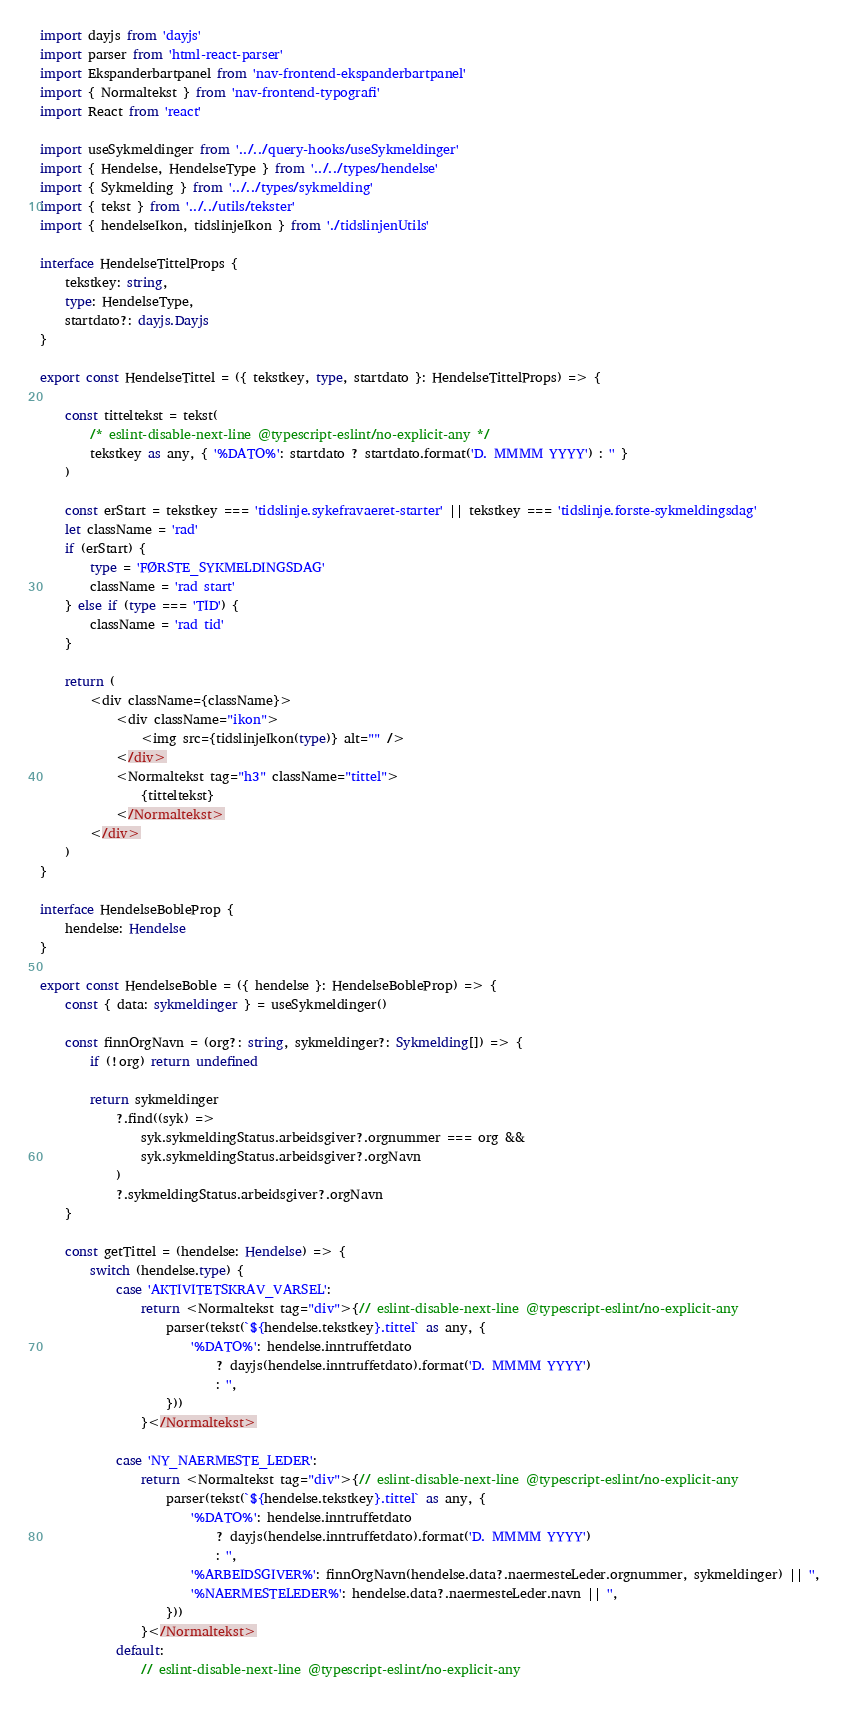<code> <loc_0><loc_0><loc_500><loc_500><_TypeScript_>import dayjs from 'dayjs'
import parser from 'html-react-parser'
import Ekspanderbartpanel from 'nav-frontend-ekspanderbartpanel'
import { Normaltekst } from 'nav-frontend-typografi'
import React from 'react'

import useSykmeldinger from '../../query-hooks/useSykmeldinger'
import { Hendelse, HendelseType } from '../../types/hendelse'
import { Sykmelding } from '../../types/sykmelding'
import { tekst } from '../../utils/tekster'
import { hendelseIkon, tidslinjeIkon } from './tidslinjenUtils'

interface HendelseTittelProps {
    tekstkey: string,
    type: HendelseType,
    startdato?: dayjs.Dayjs
}

export const HendelseTittel = ({ tekstkey, type, startdato }: HendelseTittelProps) => {

    const titteltekst = tekst(
        /* eslint-disable-next-line @typescript-eslint/no-explicit-any */
        tekstkey as any, { '%DATO%': startdato ? startdato.format('D. MMMM YYYY') : '' }
    )

    const erStart = tekstkey === 'tidslinje.sykefravaeret-starter' || tekstkey === 'tidslinje.forste-sykmeldingsdag'
    let className = 'rad'
    if (erStart) {
        type = 'FØRSTE_SYKMELDINGSDAG'
        className = 'rad start'
    } else if (type === 'TID') {
        className = 'rad tid'
    }

    return (
        <div className={className}>
            <div className="ikon">
                <img src={tidslinjeIkon(type)} alt="" />
            </div>
            <Normaltekst tag="h3" className="tittel">
                {titteltekst}
            </Normaltekst>
        </div>
    )
}

interface HendelseBobleProp {
    hendelse: Hendelse
}

export const HendelseBoble = ({ hendelse }: HendelseBobleProp) => {
    const { data: sykmeldinger } = useSykmeldinger()

    const finnOrgNavn = (org?: string, sykmeldinger?: Sykmelding[]) => {
        if (!org) return undefined

        return sykmeldinger
            ?.find((syk) =>
                syk.sykmeldingStatus.arbeidsgiver?.orgnummer === org &&
                syk.sykmeldingStatus.arbeidsgiver?.orgNavn
            )
            ?.sykmeldingStatus.arbeidsgiver?.orgNavn
    }

    const getTittel = (hendelse: Hendelse) => {
        switch (hendelse.type) {
            case 'AKTIVITETSKRAV_VARSEL':
                return <Normaltekst tag="div">{// eslint-disable-next-line @typescript-eslint/no-explicit-any
                    parser(tekst(`${hendelse.tekstkey}.tittel` as any, {
                        '%DATO%': hendelse.inntruffetdato
                            ? dayjs(hendelse.inntruffetdato).format('D. MMMM YYYY')
                            : '',
                    }))
                }</Normaltekst>

            case 'NY_NAERMESTE_LEDER':
                return <Normaltekst tag="div">{// eslint-disable-next-line @typescript-eslint/no-explicit-any
                    parser(tekst(`${hendelse.tekstkey}.tittel` as any, {
                        '%DATO%': hendelse.inntruffetdato
                            ? dayjs(hendelse.inntruffetdato).format('D. MMMM YYYY')
                            : '',
                        '%ARBEIDSGIVER%': finnOrgNavn(hendelse.data?.naermesteLeder.orgnummer, sykmeldinger) || '',
                        '%NAERMESTELEDER%': hendelse.data?.naermesteLeder.navn || '',
                    }))
                }</Normaltekst>
            default:
                // eslint-disable-next-line @typescript-eslint/no-explicit-any</code> 